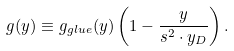Convert formula to latex. <formula><loc_0><loc_0><loc_500><loc_500>g ( y ) \equiv g _ { g l u e } ( y ) \left ( 1 - \frac { y } { s ^ { 2 } \cdot y _ { D } } \right ) .</formula> 